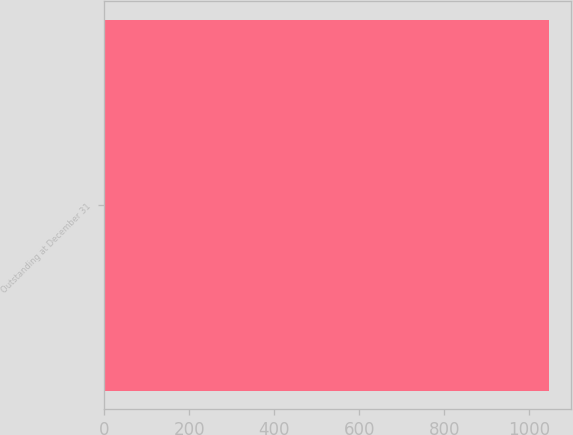<chart> <loc_0><loc_0><loc_500><loc_500><bar_chart><fcel>Outstanding at December 31<nl><fcel>1046<nl></chart> 